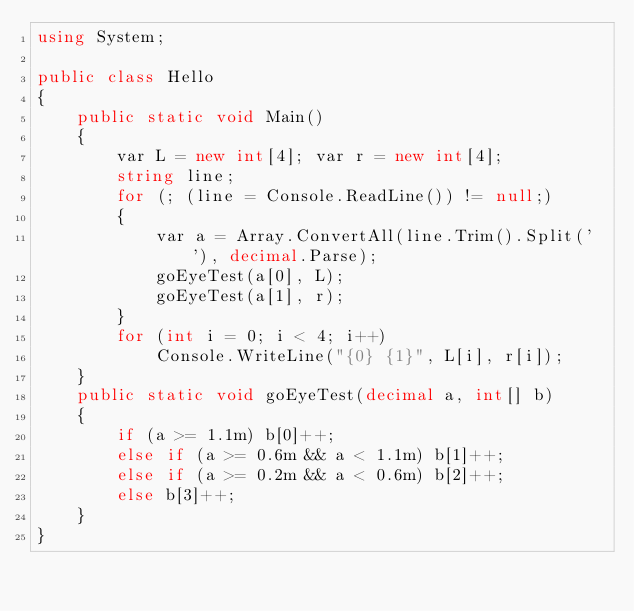<code> <loc_0><loc_0><loc_500><loc_500><_C#_>using System;

public class Hello
{
    public static void Main()
    {
        var L = new int[4]; var r = new int[4];
        string line;
        for (; (line = Console.ReadLine()) != null;)
        {
            var a = Array.ConvertAll(line.Trim().Split(' '), decimal.Parse);
            goEyeTest(a[0], L);
            goEyeTest(a[1], r);
        }
        for (int i = 0; i < 4; i++)
            Console.WriteLine("{0} {1}", L[i], r[i]);
    }
    public static void goEyeTest(decimal a, int[] b)
    {
        if (a >= 1.1m) b[0]++;
        else if (a >= 0.6m && a < 1.1m) b[1]++;
        else if (a >= 0.2m && a < 0.6m) b[2]++;
        else b[3]++;
    }
}</code> 